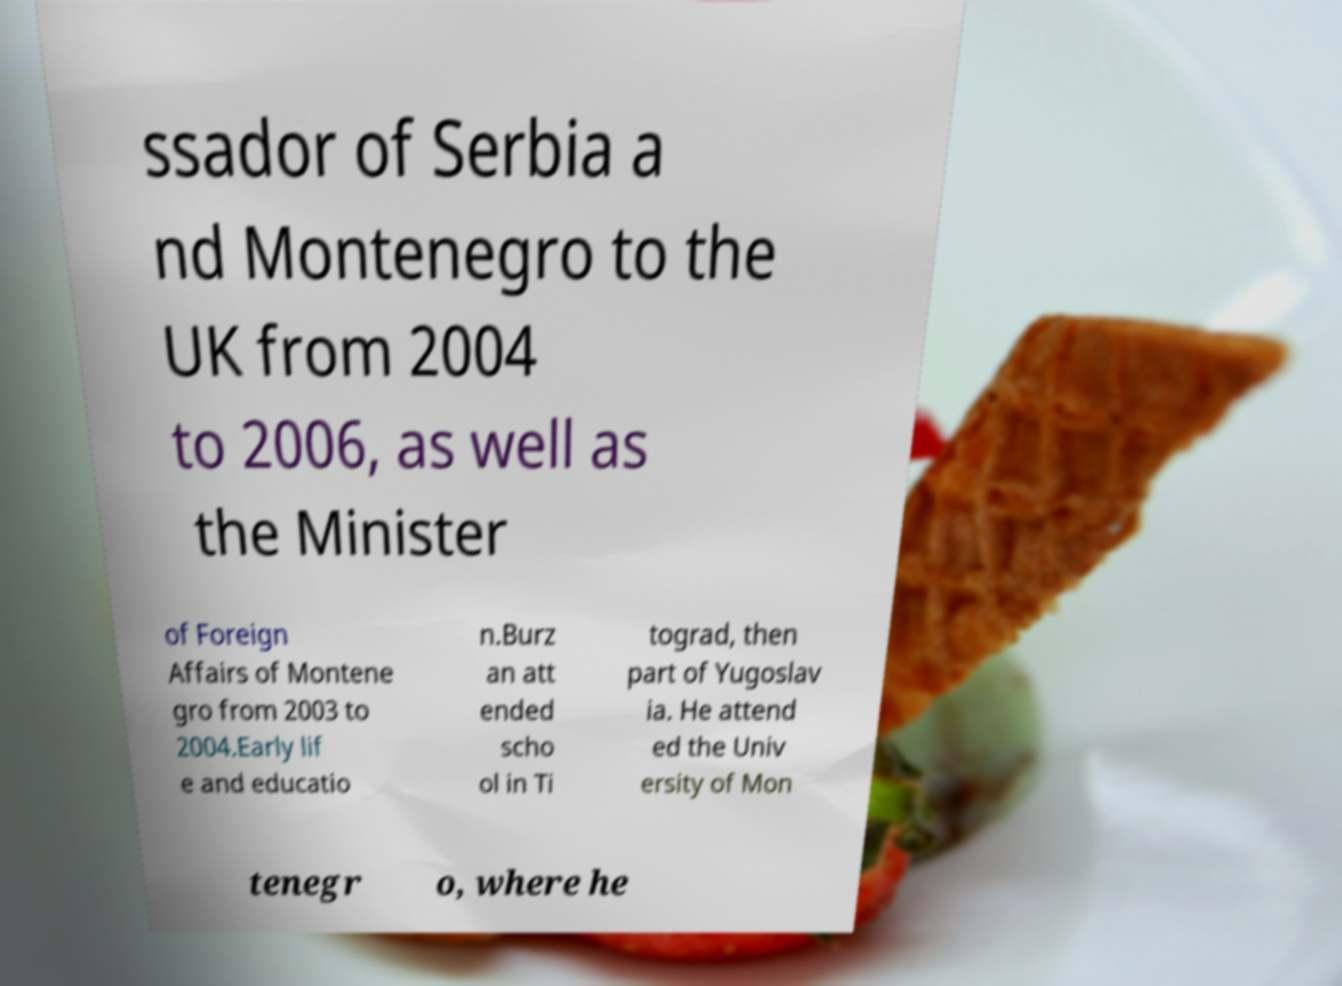Can you read and provide the text displayed in the image?This photo seems to have some interesting text. Can you extract and type it out for me? ssador of Serbia a nd Montenegro to the UK from 2004 to 2006, as well as the Minister of Foreign Affairs of Montene gro from 2003 to 2004.Early lif e and educatio n.Burz an att ended scho ol in Ti tograd, then part of Yugoslav ia. He attend ed the Univ ersity of Mon tenegr o, where he 